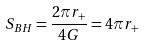<formula> <loc_0><loc_0><loc_500><loc_500>S _ { B H } = \frac { 2 \pi r _ { + } } { 4 G } = 4 \pi r _ { + }</formula> 